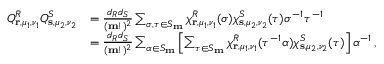Convert formula to latex. <formula><loc_0><loc_0><loc_500><loc_500>\begin{array} { r l } { Q _ { r , \mu _ { 1 } , \nu _ { 1 } } ^ { R } Q _ { s , \mu _ { 2 } , \nu _ { 2 } } ^ { S } } & { = \frac { d _ { R } d _ { S } } { ( m ! ) ^ { 2 } } \sum _ { \sigma , \tau \in S _ { m } } \chi _ { r , \mu _ { 1 } , \nu _ { 1 } } ^ { R } ( \sigma ) \chi _ { s , \mu _ { 2 } , \nu _ { 2 } } ^ { S } ( \tau ) \sigma ^ { - 1 } \tau ^ { - 1 } } \\ & { = \frac { d _ { R } d _ { S } } { ( m ! ) ^ { 2 } } \sum _ { \alpha \in S _ { m } } \left [ \sum _ { \tau \in S _ { m } } \chi _ { r , \mu _ { 1 } , \nu _ { 1 } } ^ { R } ( \tau ^ { - 1 } \alpha ) \chi _ { s , \mu _ { 2 } , \nu _ { 2 } } ^ { S } ( \tau ) \right ] \alpha ^ { - 1 } \, , } \end{array}</formula> 